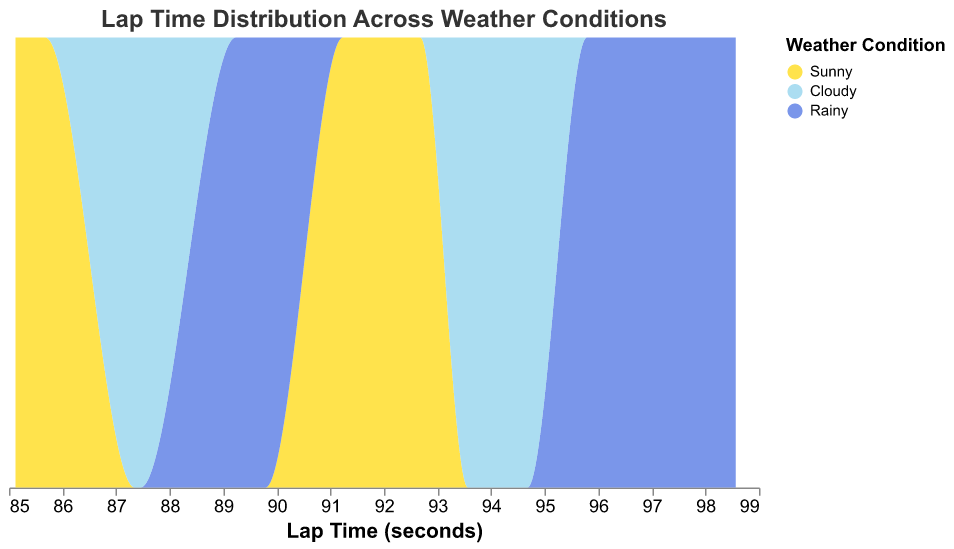What's the title of the plot? The title of the plot is displayed at the top of the figure.
Answer: Lap Time Distribution Across Weather Conditions What are the different weather conditions depicted in the plot? The different weather conditions can be seen by looking at the color legend in the plot.
Answer: Sunny, Cloudy, Rainy How is the x-axis labeled? The x-axis label is given at the bottom of the figure indicating the measurement it represents.
Answer: Lap Time (seconds) Which weather condition shows the slowest average lap times? By observing the density plot, the rightmost distribution indicates slower lap times.
Answer: Rainy What does the color gold represent in this plot? The color legend provides information about the corresponding weather condition for each color.
Answer: Sunny Compare the lap times for Sunny and Cloudy weather conditions. Which one generally has faster lap times? By comparing the density distributions, the one centered around lower lap times is faster.
Answer: Sunny Which weather condition has the most spread (variance) in lap times? The spread of the distribution can be identified by looking at how wide the area spans along the x-axis.
Answer: Rainy In which weather condition do drivers tend to have the most consistent lap times? Consistency is shown by the narrowest spread in the lap time distribution.
Answer: Sunny How do the lap times under Cloudy conditions compare to those under Rainy conditions? By comparing the density plots, one can see if the lap times under Cloudy conditions are generally faster or slower than those under Rainy conditions.
Answer: Cloudy conditions have faster lap times than Rainy conditions Are the lap times for each weather condition normalized in the plot? The y-axis stack field in "normalize" mode suggests normalization of lap time counts across weather conditions.
Answer: Yes 